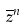Convert formula to latex. <formula><loc_0><loc_0><loc_500><loc_500>\overline { z } ^ { n }</formula> 